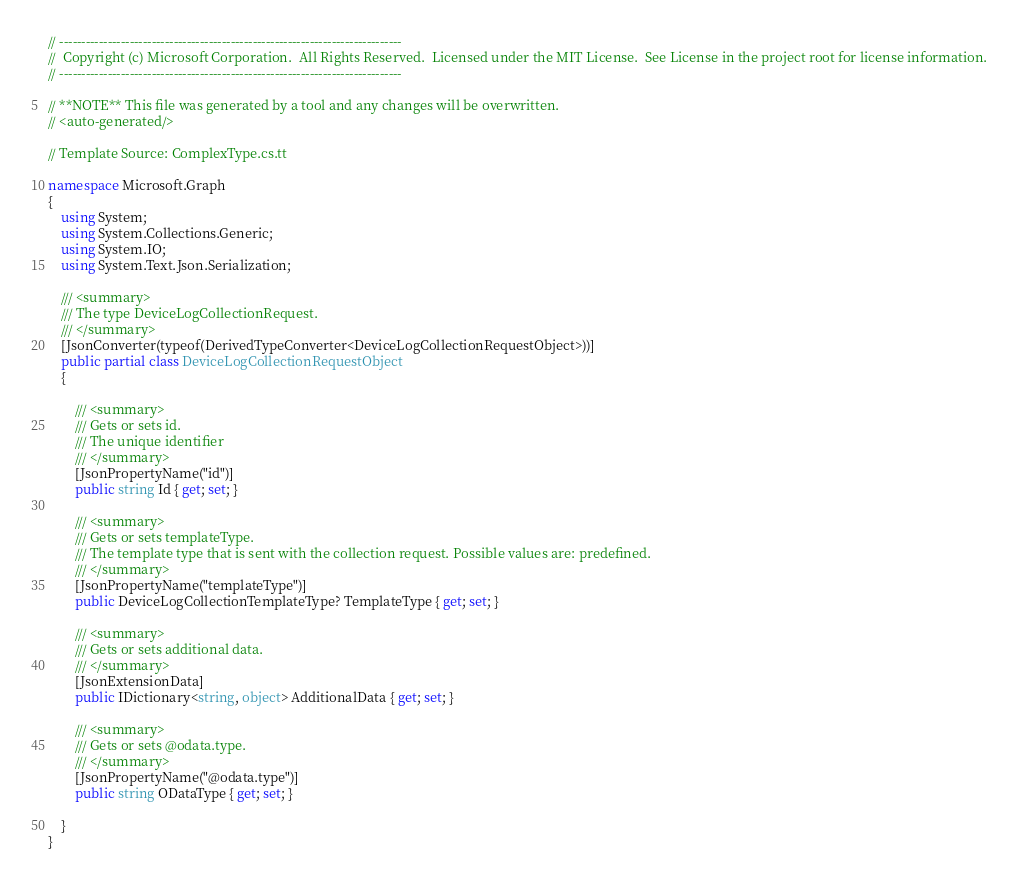Convert code to text. <code><loc_0><loc_0><loc_500><loc_500><_C#_>// ------------------------------------------------------------------------------
//  Copyright (c) Microsoft Corporation.  All Rights Reserved.  Licensed under the MIT License.  See License in the project root for license information.
// ------------------------------------------------------------------------------

// **NOTE** This file was generated by a tool and any changes will be overwritten.
// <auto-generated/>

// Template Source: ComplexType.cs.tt

namespace Microsoft.Graph
{
    using System;
    using System.Collections.Generic;
    using System.IO;
    using System.Text.Json.Serialization;

    /// <summary>
    /// The type DeviceLogCollectionRequest.
    /// </summary>
    [JsonConverter(typeof(DerivedTypeConverter<DeviceLogCollectionRequestObject>))]
    public partial class DeviceLogCollectionRequestObject
    {

        /// <summary>
        /// Gets or sets id.
        /// The unique identifier
        /// </summary>
        [JsonPropertyName("id")]
        public string Id { get; set; }
    
        /// <summary>
        /// Gets or sets templateType.
        /// The template type that is sent with the collection request. Possible values are: predefined.
        /// </summary>
        [JsonPropertyName("templateType")]
        public DeviceLogCollectionTemplateType? TemplateType { get; set; }
    
        /// <summary>
        /// Gets or sets additional data.
        /// </summary>
        [JsonExtensionData]
        public IDictionary<string, object> AdditionalData { get; set; }

        /// <summary>
        /// Gets or sets @odata.type.
        /// </summary>
        [JsonPropertyName("@odata.type")]
        public string ODataType { get; set; }
    
    }
}
</code> 